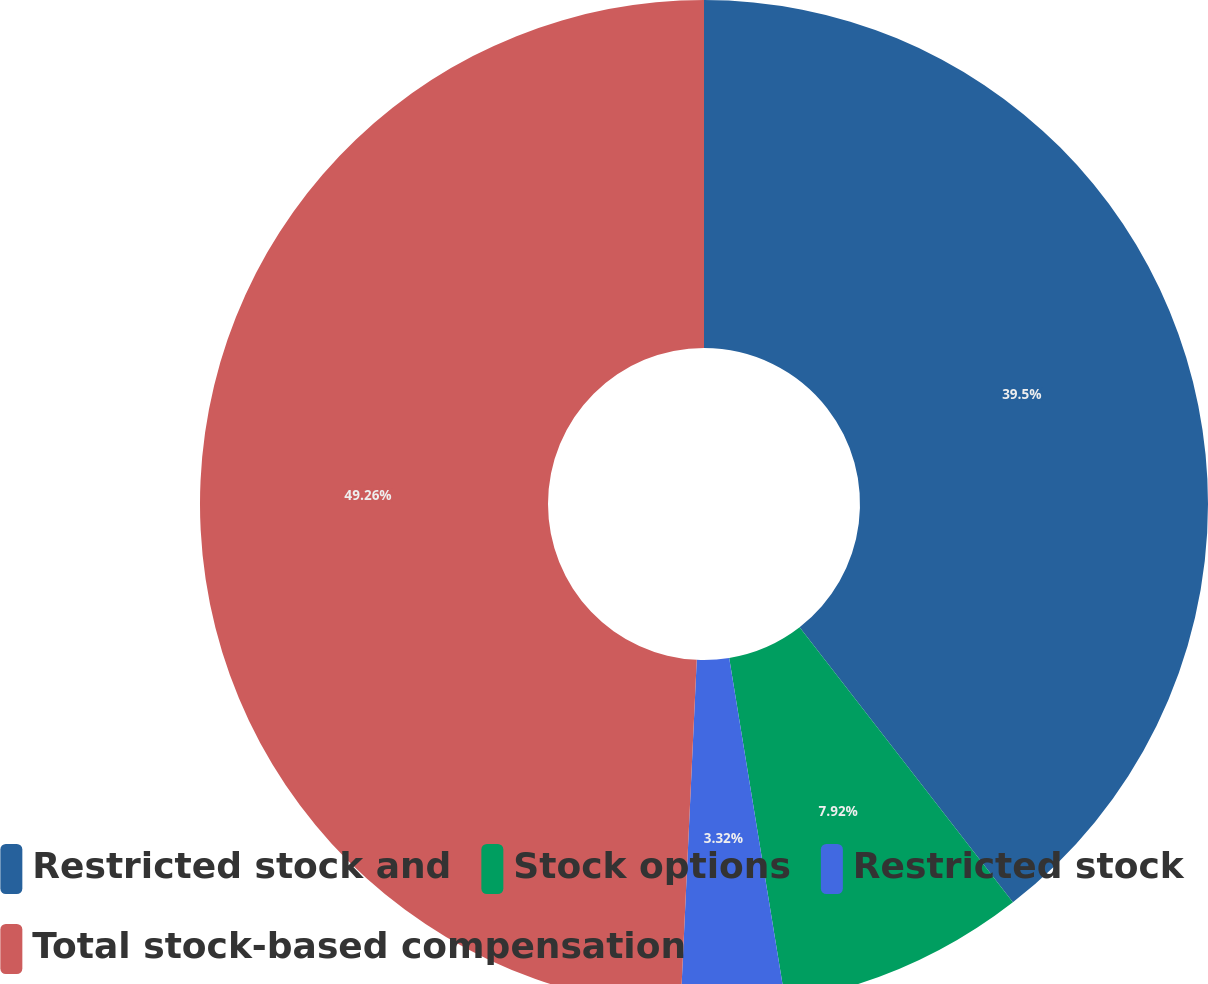<chart> <loc_0><loc_0><loc_500><loc_500><pie_chart><fcel>Restricted stock and<fcel>Stock options<fcel>Restricted stock<fcel>Total stock-based compensation<nl><fcel>39.5%<fcel>7.92%<fcel>3.32%<fcel>49.26%<nl></chart> 